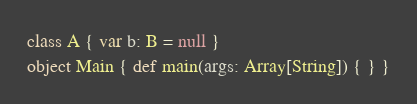<code> <loc_0><loc_0><loc_500><loc_500><_Scala_>class A { var b: B = null }
object Main { def main(args: Array[String]) { } }
</code> 